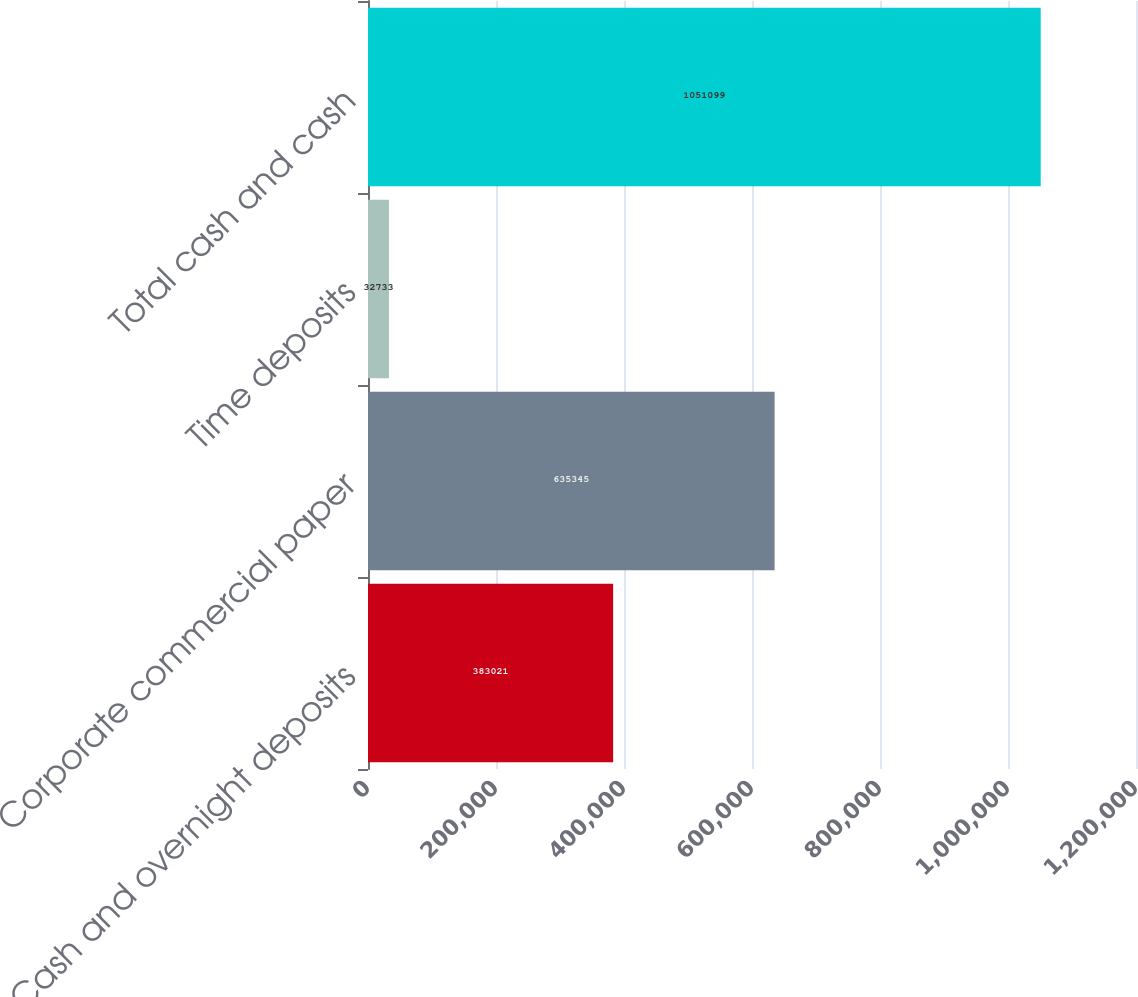Convert chart. <chart><loc_0><loc_0><loc_500><loc_500><bar_chart><fcel>Cash and overnight deposits<fcel>Corporate commercial paper<fcel>Time deposits<fcel>Total cash and cash<nl><fcel>383021<fcel>635345<fcel>32733<fcel>1.0511e+06<nl></chart> 